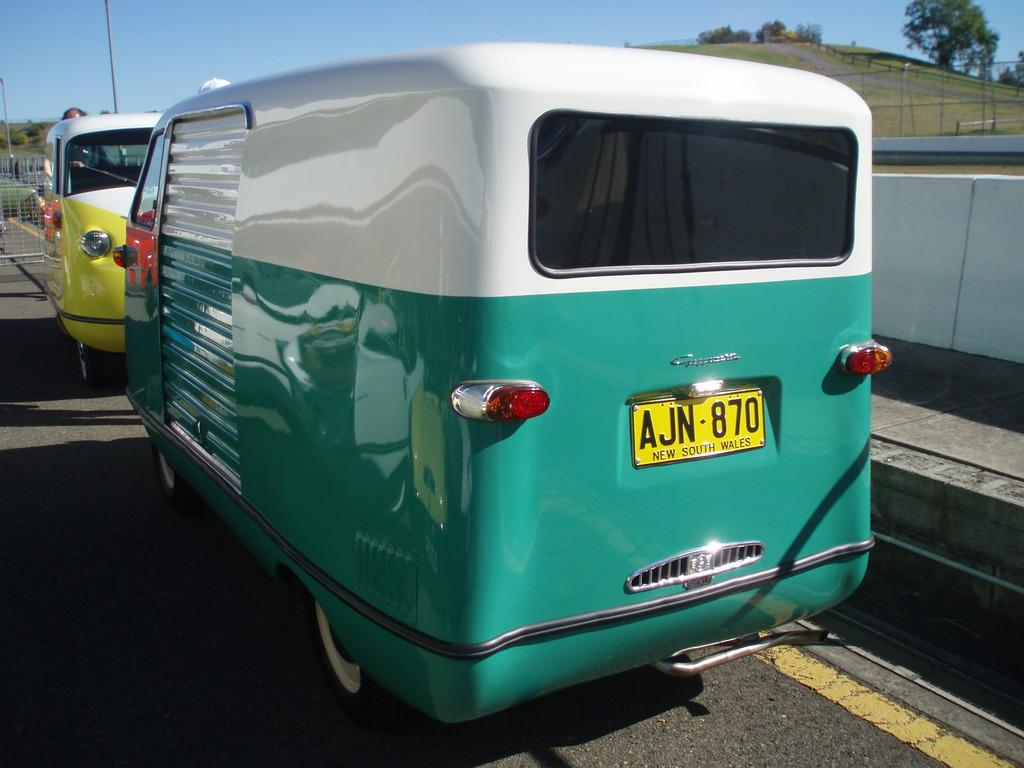Provide a one-sentence caption for the provided image. A sporty two-colored trailer has a license plate reading AJN-870. 